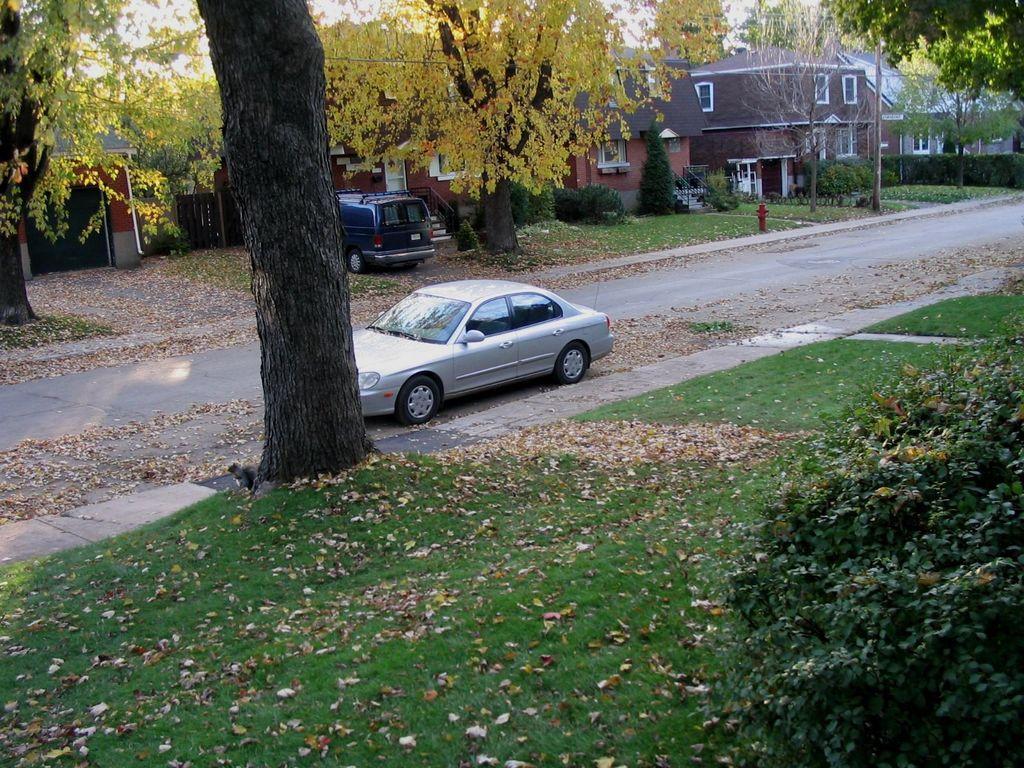How would you summarize this image in a sentence or two? This image consists of a car in silver color. At the bottom, there is green grass on the ground. On the right, there are plants. In the front, there are many trees and houses. And there is another car in blue color. In the middle, there is a road. 